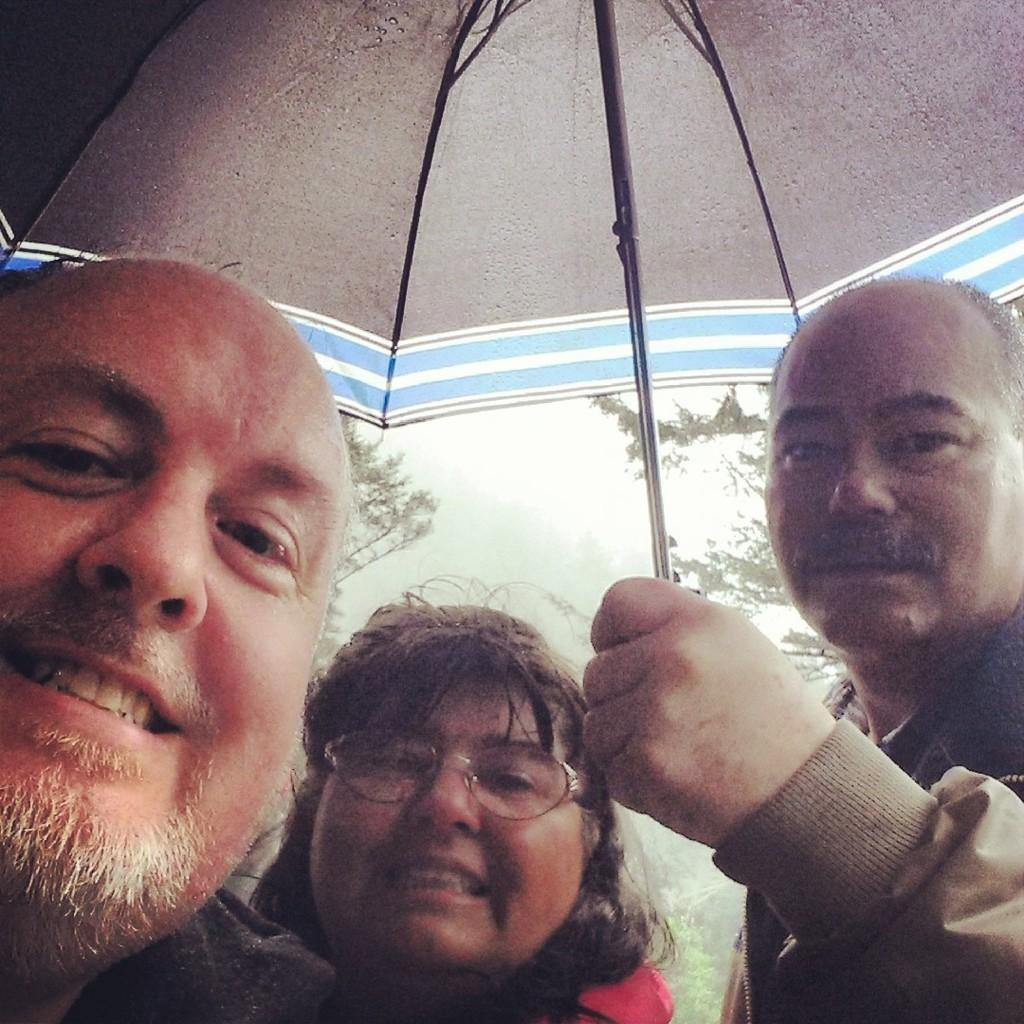How many people are in the image? There are three people in the image. What are the people in the image doing? The three people are taking a photo. Can you describe any objects being held by the people? One of the people is holding an umbrella. What can be seen in the background of the image? There are trees visible in the background of the image. What type of soup is being served at the church in the image? There is no church or soup present in the image; it features three people taking a photo with an umbrella and trees in the background. 